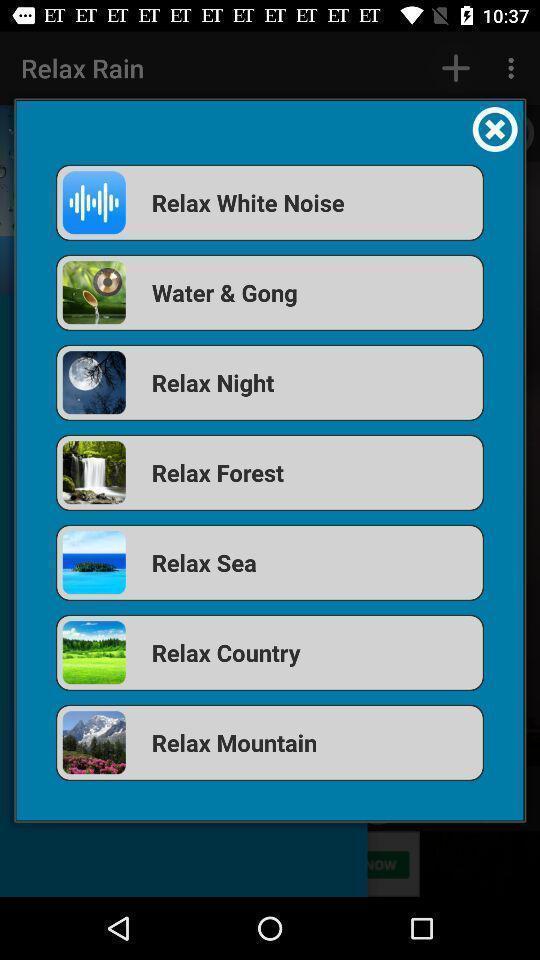Summarize the main components in this picture. Pop up showing list of android applications. 